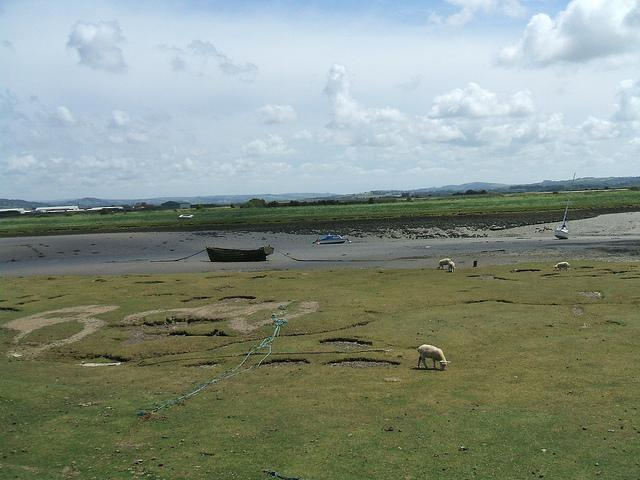What has dried up and stopped the boats from moving? water 